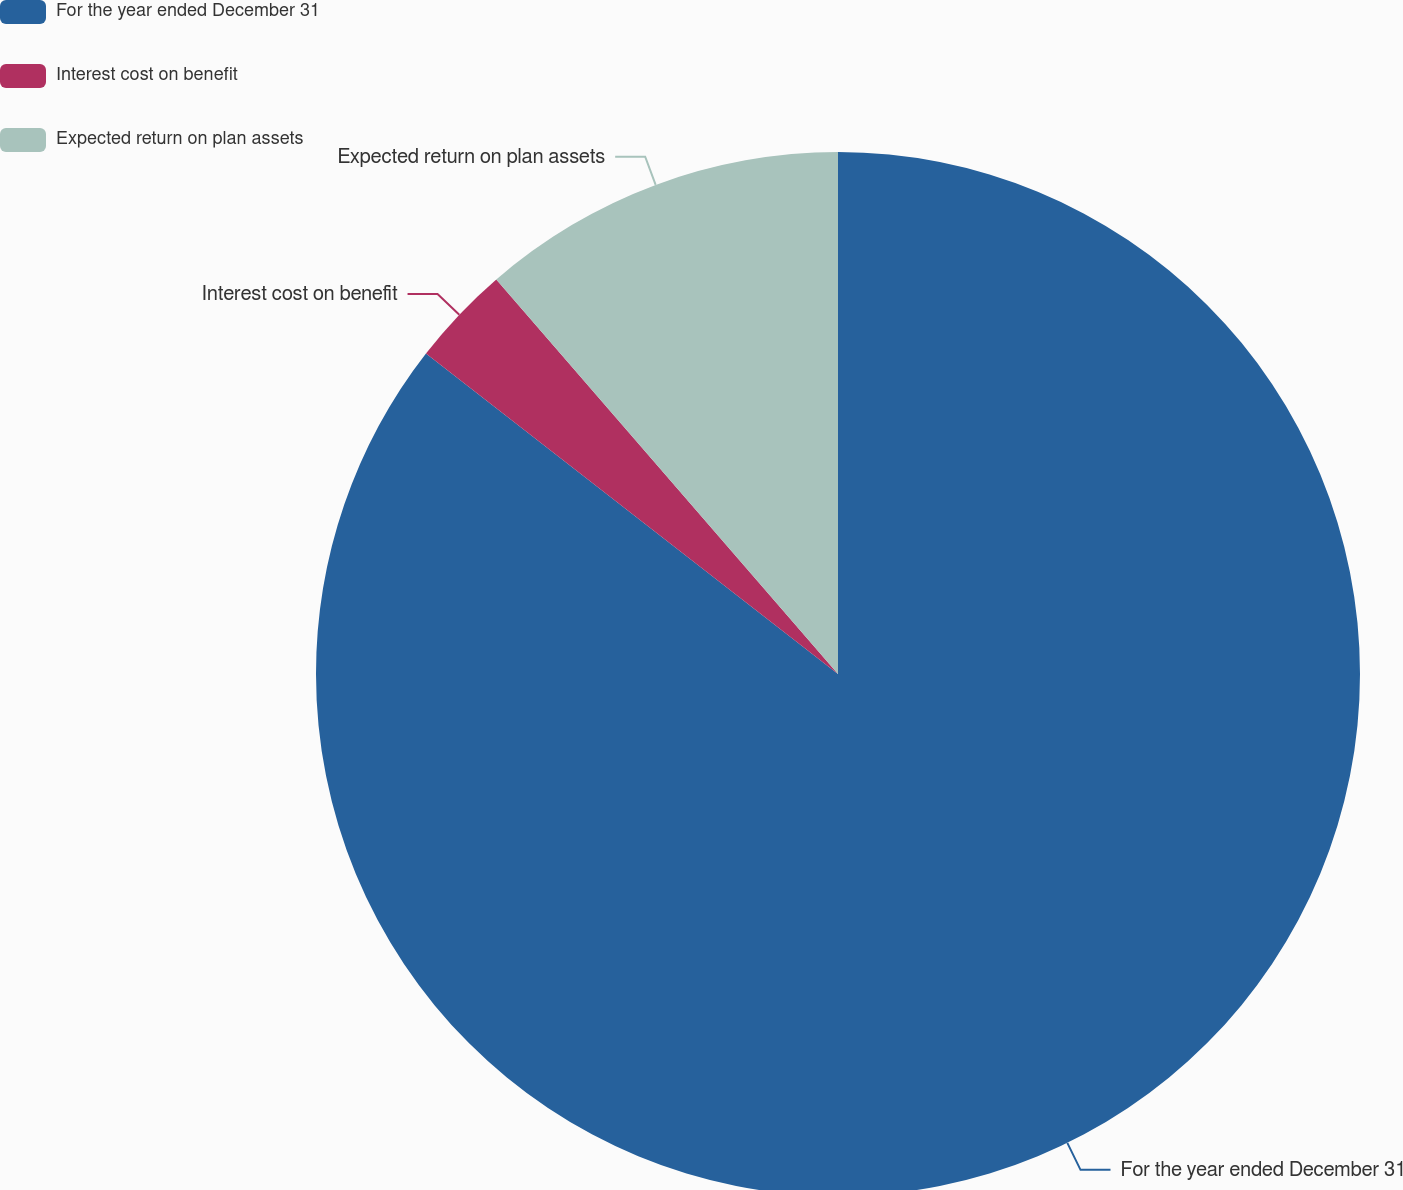Convert chart to OTSL. <chart><loc_0><loc_0><loc_500><loc_500><pie_chart><fcel>For the year ended December 31<fcel>Interest cost on benefit<fcel>Expected return on plan assets<nl><fcel>85.53%<fcel>3.12%<fcel>11.36%<nl></chart> 